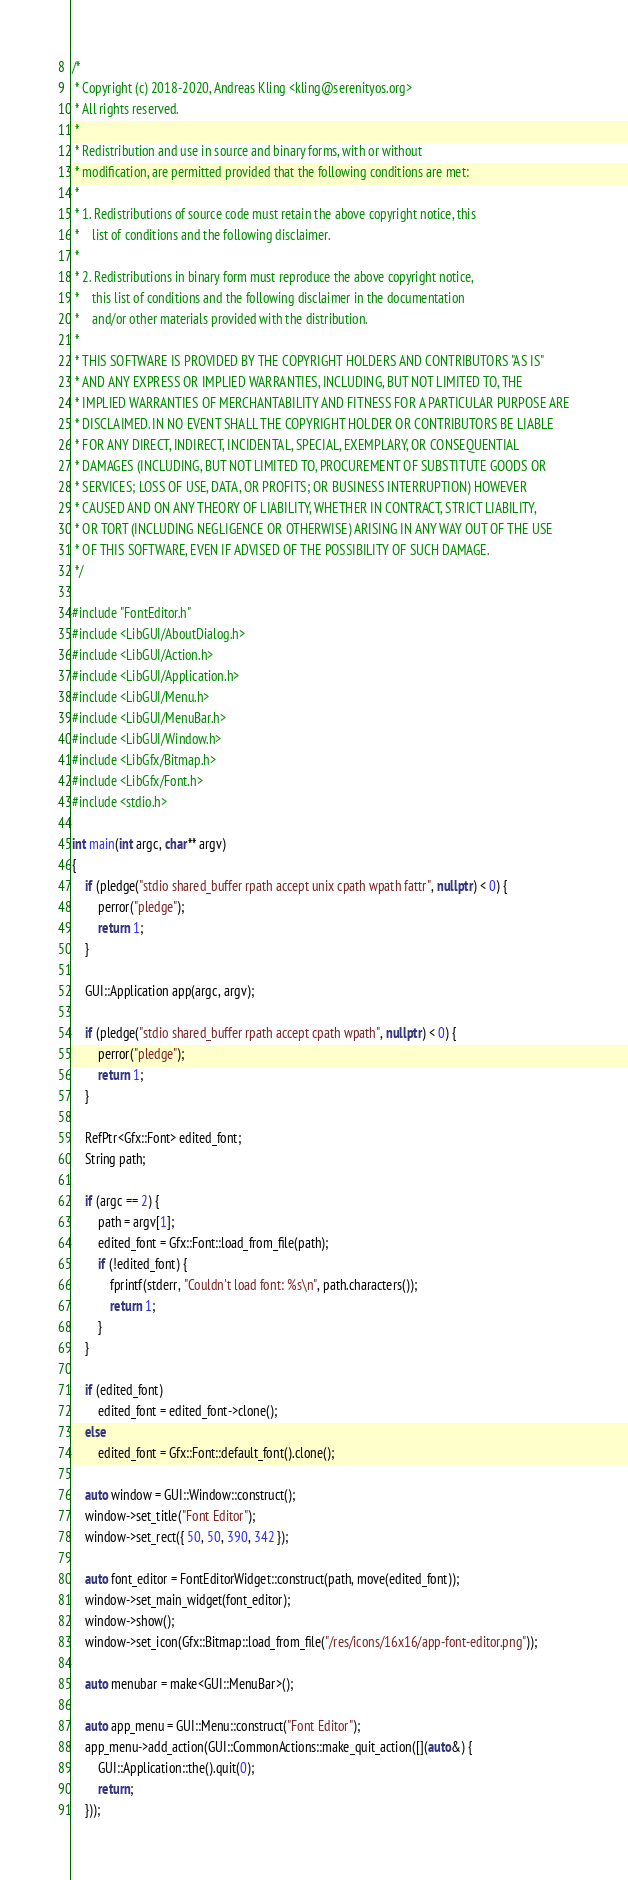Convert code to text. <code><loc_0><loc_0><loc_500><loc_500><_C++_>/*
 * Copyright (c) 2018-2020, Andreas Kling <kling@serenityos.org>
 * All rights reserved.
 *
 * Redistribution and use in source and binary forms, with or without
 * modification, are permitted provided that the following conditions are met:
 *
 * 1. Redistributions of source code must retain the above copyright notice, this
 *    list of conditions and the following disclaimer.
 *
 * 2. Redistributions in binary form must reproduce the above copyright notice,
 *    this list of conditions and the following disclaimer in the documentation
 *    and/or other materials provided with the distribution.
 *
 * THIS SOFTWARE IS PROVIDED BY THE COPYRIGHT HOLDERS AND CONTRIBUTORS "AS IS"
 * AND ANY EXPRESS OR IMPLIED WARRANTIES, INCLUDING, BUT NOT LIMITED TO, THE
 * IMPLIED WARRANTIES OF MERCHANTABILITY AND FITNESS FOR A PARTICULAR PURPOSE ARE
 * DISCLAIMED. IN NO EVENT SHALL THE COPYRIGHT HOLDER OR CONTRIBUTORS BE LIABLE
 * FOR ANY DIRECT, INDIRECT, INCIDENTAL, SPECIAL, EXEMPLARY, OR CONSEQUENTIAL
 * DAMAGES (INCLUDING, BUT NOT LIMITED TO, PROCUREMENT OF SUBSTITUTE GOODS OR
 * SERVICES; LOSS OF USE, DATA, OR PROFITS; OR BUSINESS INTERRUPTION) HOWEVER
 * CAUSED AND ON ANY THEORY OF LIABILITY, WHETHER IN CONTRACT, STRICT LIABILITY,
 * OR TORT (INCLUDING NEGLIGENCE OR OTHERWISE) ARISING IN ANY WAY OUT OF THE USE
 * OF THIS SOFTWARE, EVEN IF ADVISED OF THE POSSIBILITY OF SUCH DAMAGE.
 */

#include "FontEditor.h"
#include <LibGUI/AboutDialog.h>
#include <LibGUI/Action.h>
#include <LibGUI/Application.h>
#include <LibGUI/Menu.h>
#include <LibGUI/MenuBar.h>
#include <LibGUI/Window.h>
#include <LibGfx/Bitmap.h>
#include <LibGfx/Font.h>
#include <stdio.h>

int main(int argc, char** argv)
{
    if (pledge("stdio shared_buffer rpath accept unix cpath wpath fattr", nullptr) < 0) {
        perror("pledge");
        return 1;
    }

    GUI::Application app(argc, argv);

    if (pledge("stdio shared_buffer rpath accept cpath wpath", nullptr) < 0) {
        perror("pledge");
        return 1;
    }

    RefPtr<Gfx::Font> edited_font;
    String path;

    if (argc == 2) {
        path = argv[1];
        edited_font = Gfx::Font::load_from_file(path);
        if (!edited_font) {
            fprintf(stderr, "Couldn't load font: %s\n", path.characters());
            return 1;
        }
    }

    if (edited_font)
        edited_font = edited_font->clone();
    else
        edited_font = Gfx::Font::default_font().clone();

    auto window = GUI::Window::construct();
    window->set_title("Font Editor");
    window->set_rect({ 50, 50, 390, 342 });

    auto font_editor = FontEditorWidget::construct(path, move(edited_font));
    window->set_main_widget(font_editor);
    window->show();
    window->set_icon(Gfx::Bitmap::load_from_file("/res/icons/16x16/app-font-editor.png"));

    auto menubar = make<GUI::MenuBar>();

    auto app_menu = GUI::Menu::construct("Font Editor");
    app_menu->add_action(GUI::CommonActions::make_quit_action([](auto&) {
        GUI::Application::the().quit(0);
        return;
    }));</code> 